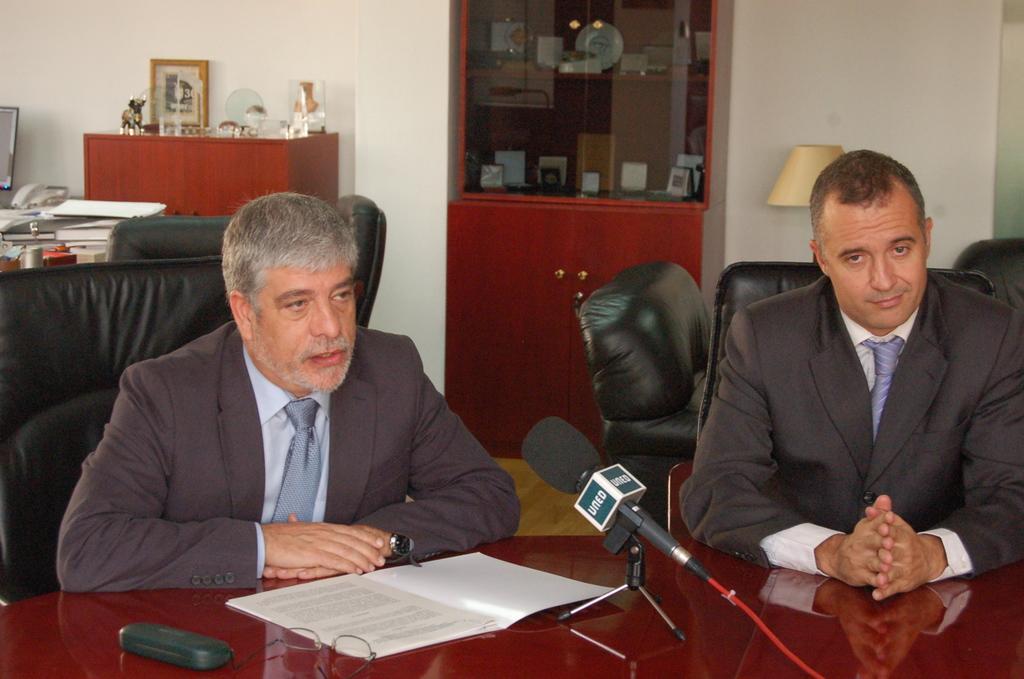How would you summarize this image in a sentence or two? There are two members sitting in the chairs in front of a table on which a book, spectacles and a mic was placed. Two of them were men. In the background there is a cupboard lamp and a wall here. There are some books placed on the table in the background. 